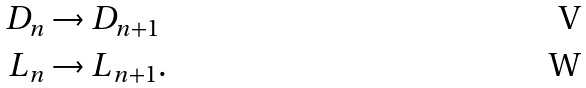<formula> <loc_0><loc_0><loc_500><loc_500>D _ { n } & \rightarrow D _ { n + 1 } \\ L _ { n } & \rightarrow L _ { n + 1 } .</formula> 